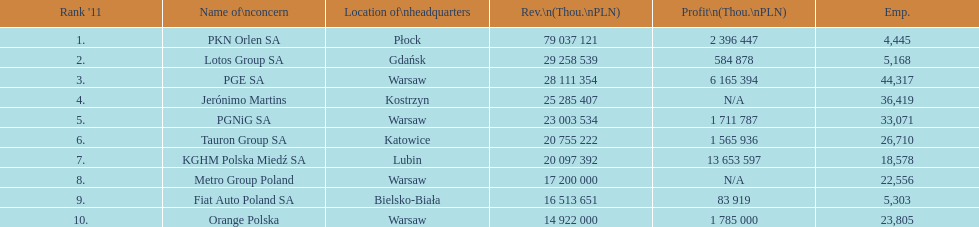What company has the top number of employees? PGE SA. 